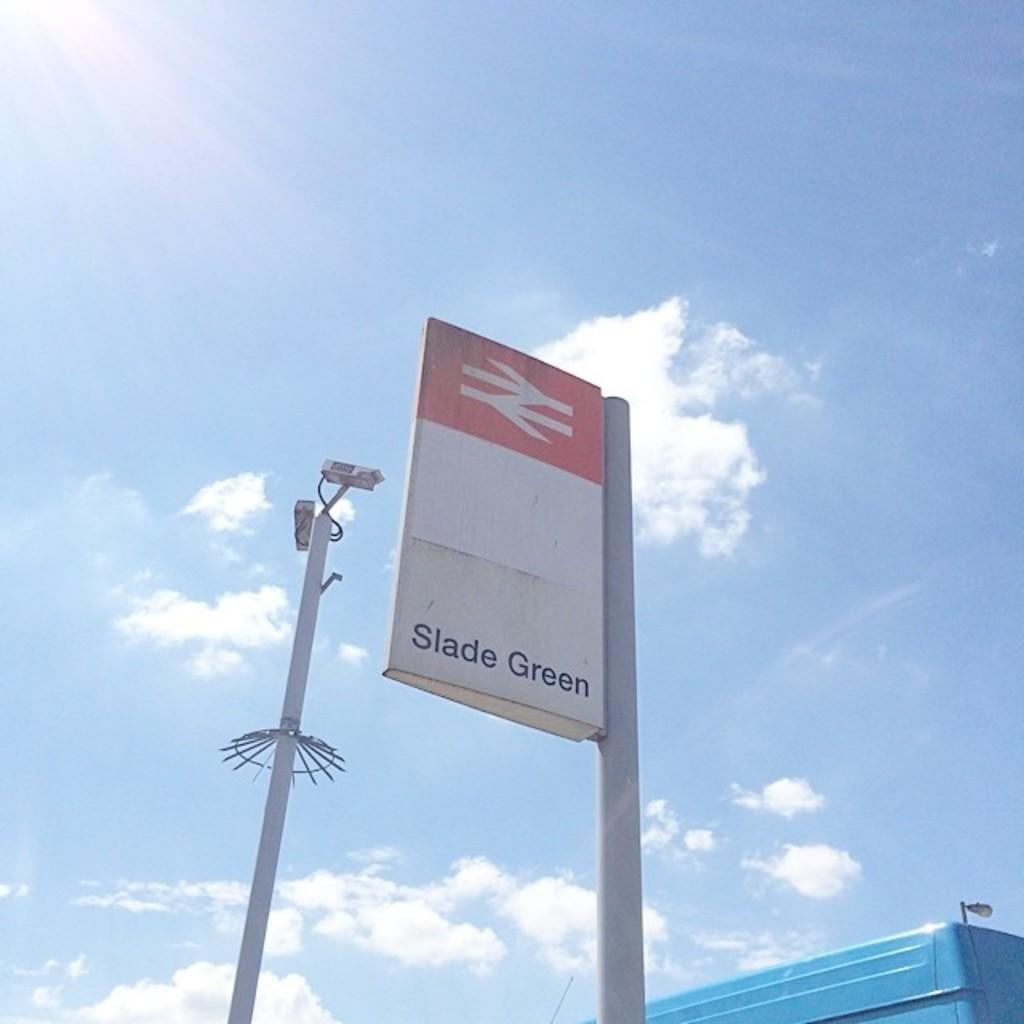<image>
Create a compact narrative representing the image presented. The weather is sunny and clear and a sign for Slade Green can be seen. 